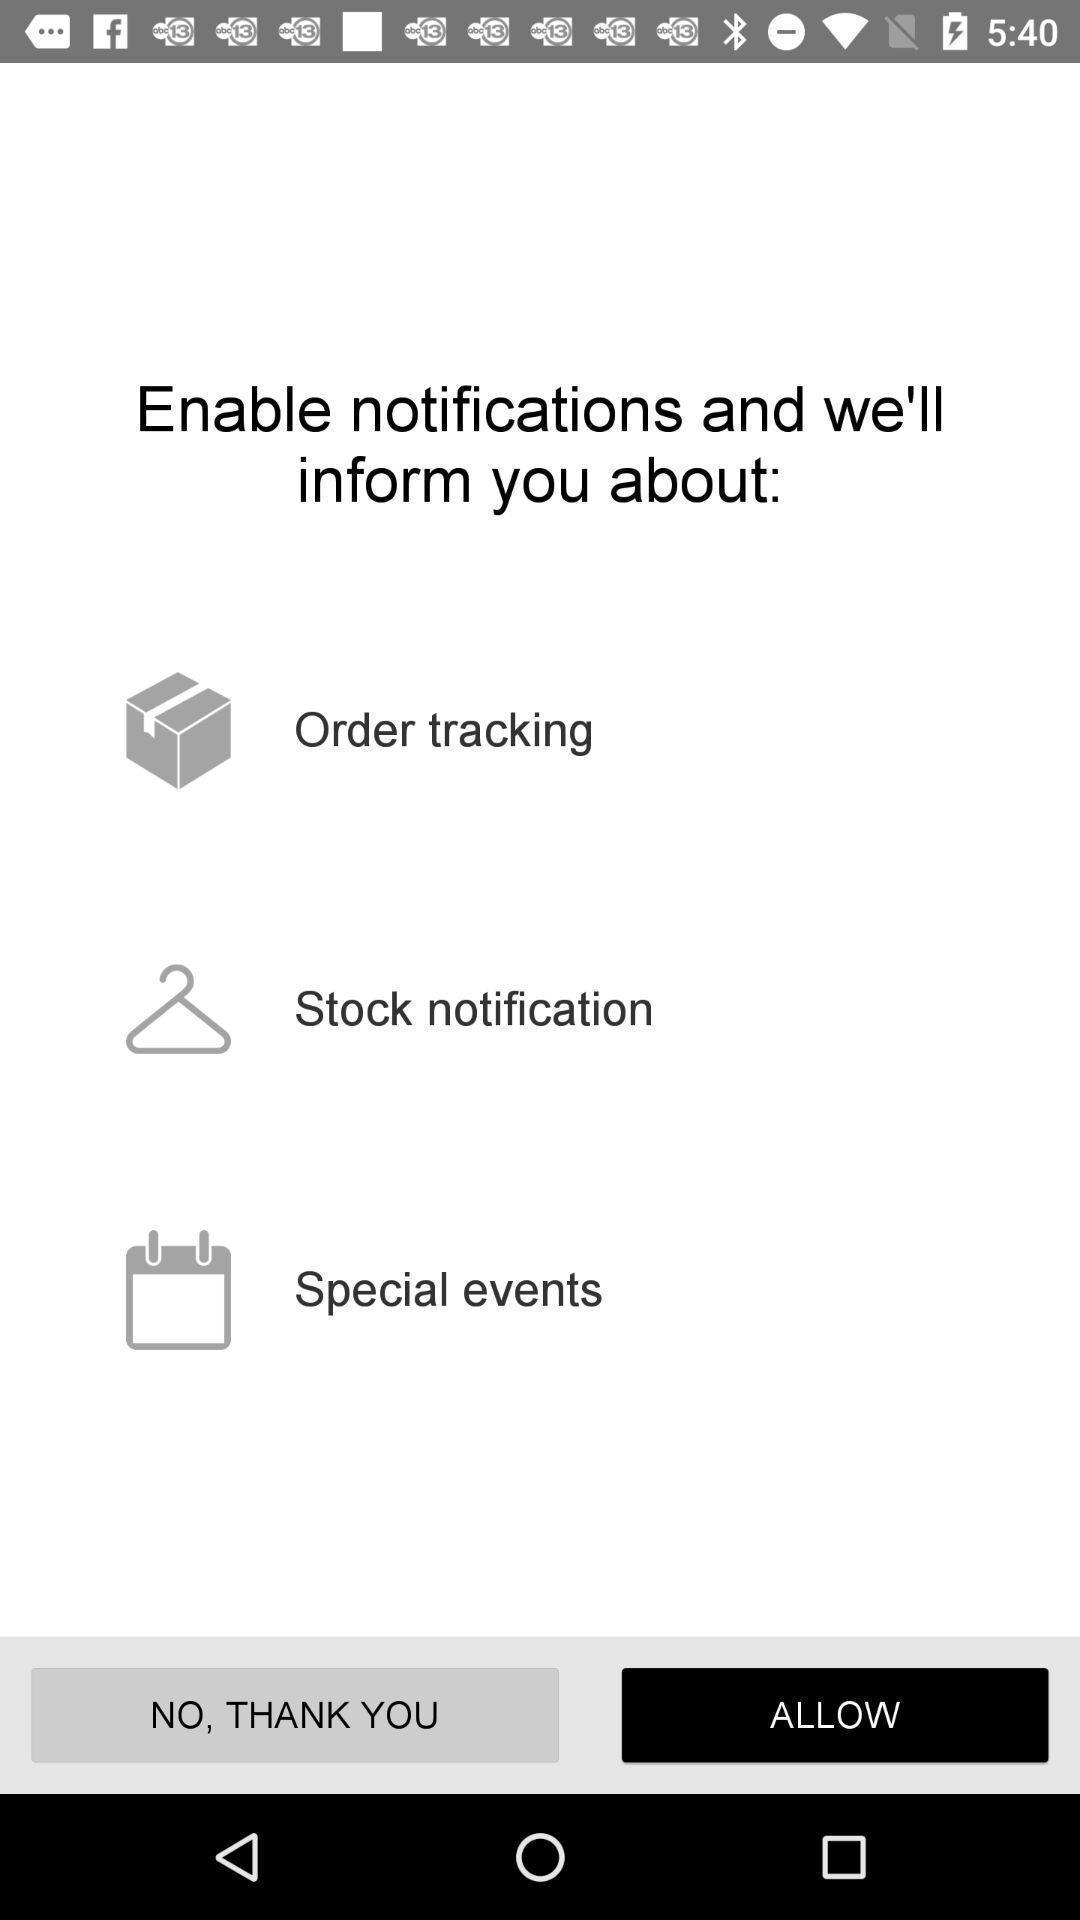Summarize the main components in this picture. Page to allow notifications for the shopping app. 